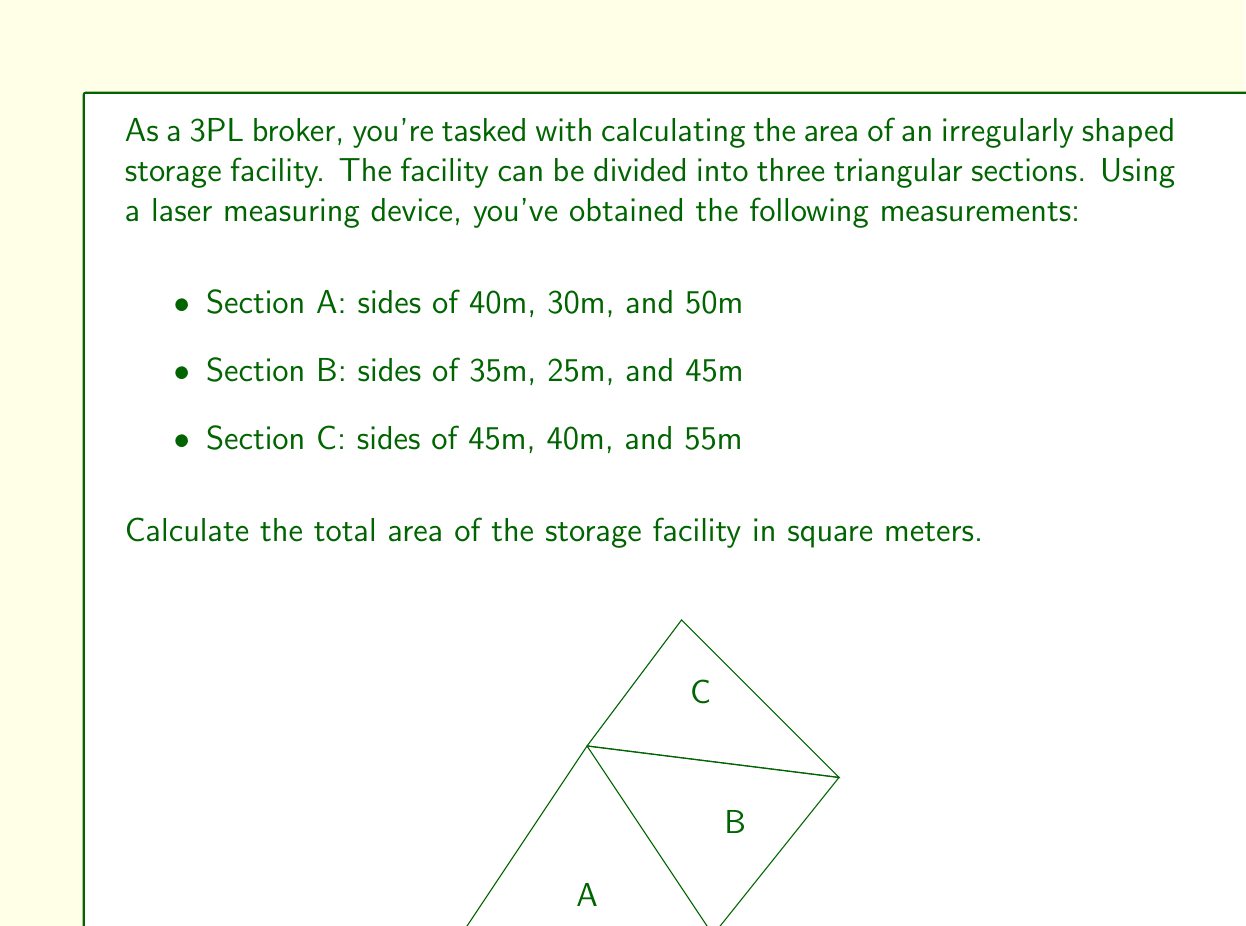What is the answer to this math problem? To solve this problem, we'll use Heron's formula to calculate the area of each triangular section and then sum them up. Heron's formula states that the area of a triangle with sides $a$, $b$, and $c$ is:

$$ A = \sqrt{s(s-a)(s-b)(s-c)} $$

where $s$ is the semi-perimeter, given by:

$$ s = \frac{a + b + c}{2} $$

Let's calculate the area of each section:

1. Section A (40m, 30m, 50m):
   $s_A = \frac{40 + 30 + 50}{2} = 60$
   $A_A = \sqrt{60(60-40)(60-30)(60-50)} = \sqrt{60 \cdot 20 \cdot 30 \cdot 10} = \sqrt{360000} = 600$ m²

2. Section B (35m, 25m, 45m):
   $s_B = \frac{35 + 25 + 45}{2} = 52.5$
   $A_B = \sqrt{52.5(52.5-35)(52.5-25)(52.5-45)} = \sqrt{52.5 \cdot 17.5 \cdot 27.5 \cdot 7.5} = \sqrt{187031.25} \approx 432.47$ m²

3. Section C (45m, 40m, 55m):
   $s_C = \frac{45 + 40 + 55}{2} = 70$
   $A_C = \sqrt{70(70-45)(70-40)(70-55)} = \sqrt{70 \cdot 25 \cdot 30 \cdot 15} = \sqrt{787500} \approx 887.41$ m²

The total area is the sum of these three sections:

$A_{total} = A_A + A_B + A_C = 600 + 432.47 + 887.41 = 1919.88$ m²
Answer: The total area of the storage facility is approximately 1919.88 square meters. 